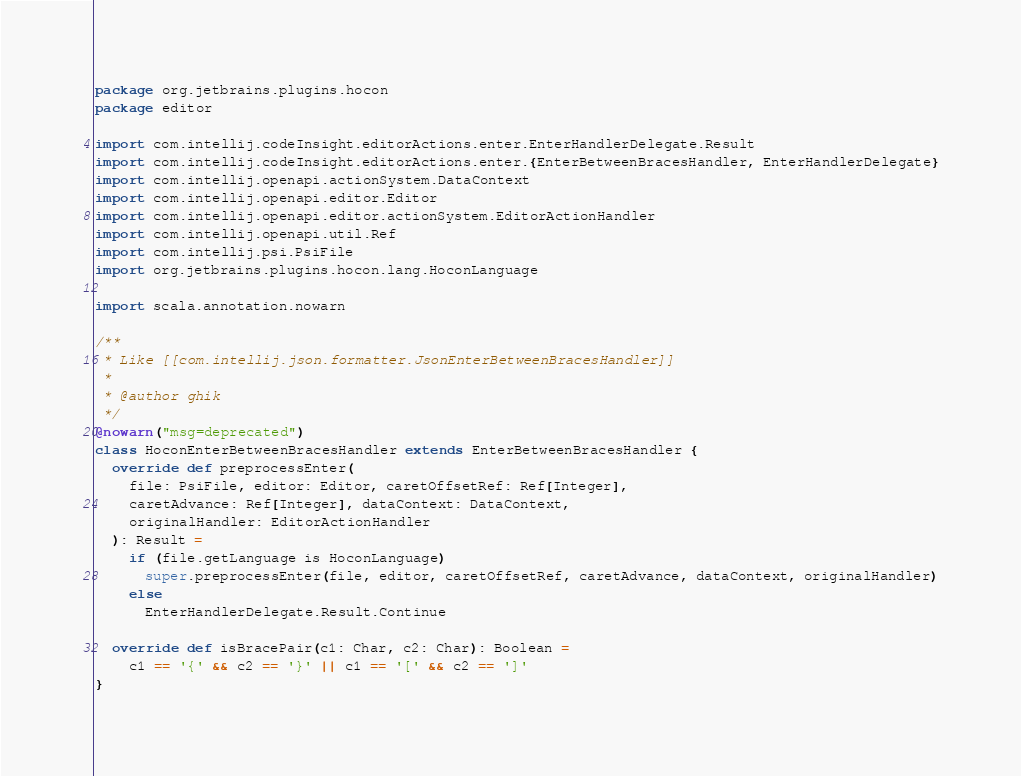Convert code to text. <code><loc_0><loc_0><loc_500><loc_500><_Scala_>package org.jetbrains.plugins.hocon
package editor

import com.intellij.codeInsight.editorActions.enter.EnterHandlerDelegate.Result
import com.intellij.codeInsight.editorActions.enter.{EnterBetweenBracesHandler, EnterHandlerDelegate}
import com.intellij.openapi.actionSystem.DataContext
import com.intellij.openapi.editor.Editor
import com.intellij.openapi.editor.actionSystem.EditorActionHandler
import com.intellij.openapi.util.Ref
import com.intellij.psi.PsiFile
import org.jetbrains.plugins.hocon.lang.HoconLanguage

import scala.annotation.nowarn

/**
 * Like [[com.intellij.json.formatter.JsonEnterBetweenBracesHandler]]
 *
 * @author ghik
 */
@nowarn("msg=deprecated")
class HoconEnterBetweenBracesHandler extends EnterBetweenBracesHandler {
  override def preprocessEnter(
    file: PsiFile, editor: Editor, caretOffsetRef: Ref[Integer],
    caretAdvance: Ref[Integer], dataContext: DataContext,
    originalHandler: EditorActionHandler
  ): Result =
    if (file.getLanguage is HoconLanguage)
      super.preprocessEnter(file, editor, caretOffsetRef, caretAdvance, dataContext, originalHandler)
    else
      EnterHandlerDelegate.Result.Continue

  override def isBracePair(c1: Char, c2: Char): Boolean =
    c1 == '{' && c2 == '}' || c1 == '[' && c2 == ']'
}
</code> 